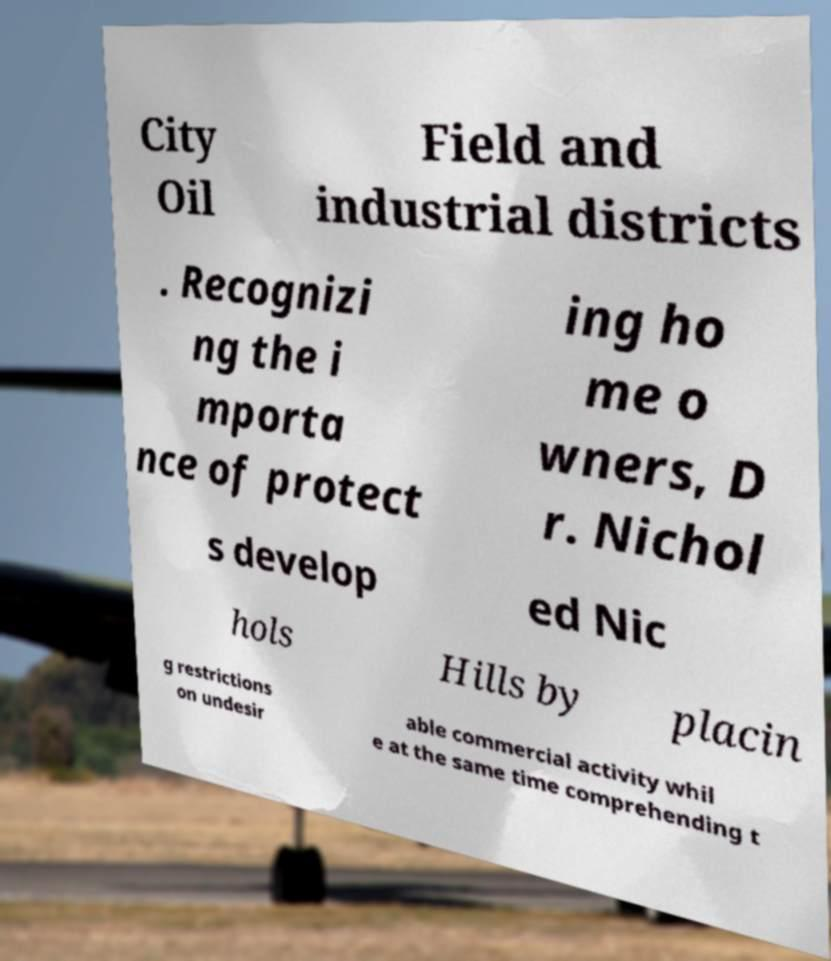Please read and relay the text visible in this image. What does it say? City Oil Field and industrial districts . Recognizi ng the i mporta nce of protect ing ho me o wners, D r. Nichol s develop ed Nic hols Hills by placin g restrictions on undesir able commercial activity whil e at the same time comprehending t 